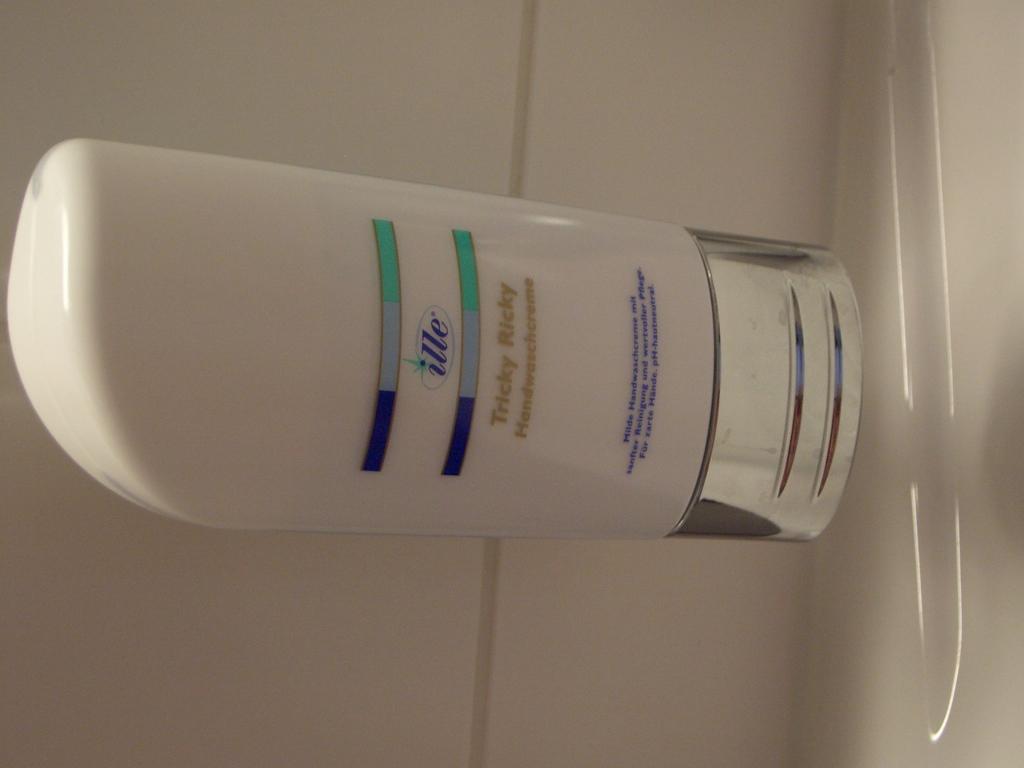What brand is that?
Keep it short and to the point. Ille. What is the scent?
Provide a short and direct response. Tricky ricky. 